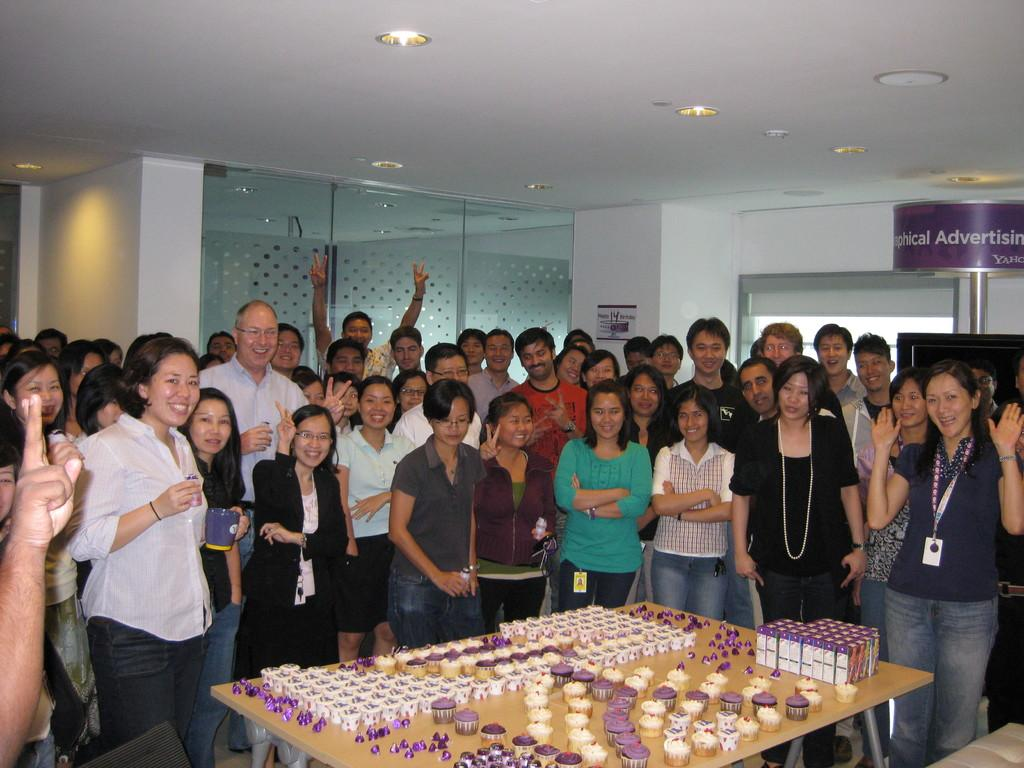What are the people in the image doing? There is a group of people standing in the image. What is in front of the group of people? There is a table in front of the group of people. What type of food items can be seen on the table? There are muffins, chocolates, and food packets on the table. What key is used to unlock the door in the image? There is no door or key present in the image; it only shows a group of people standing near a table with food items. 